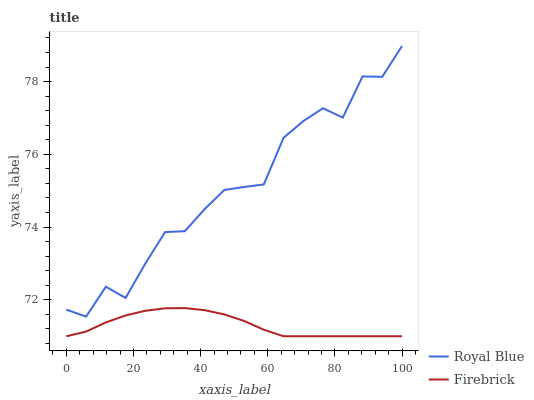Does Firebrick have the minimum area under the curve?
Answer yes or no. Yes. Does Royal Blue have the maximum area under the curve?
Answer yes or no. Yes. Does Firebrick have the maximum area under the curve?
Answer yes or no. No. Is Firebrick the smoothest?
Answer yes or no. Yes. Is Royal Blue the roughest?
Answer yes or no. Yes. Is Firebrick the roughest?
Answer yes or no. No. Does Firebrick have the lowest value?
Answer yes or no. Yes. Does Royal Blue have the highest value?
Answer yes or no. Yes. Does Firebrick have the highest value?
Answer yes or no. No. Is Firebrick less than Royal Blue?
Answer yes or no. Yes. Is Royal Blue greater than Firebrick?
Answer yes or no. Yes. Does Firebrick intersect Royal Blue?
Answer yes or no. No. 